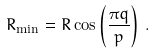Convert formula to latex. <formula><loc_0><loc_0><loc_500><loc_500>R _ { \min } = R \cos \left ( \frac { \pi q } { p } \right ) \, .</formula> 